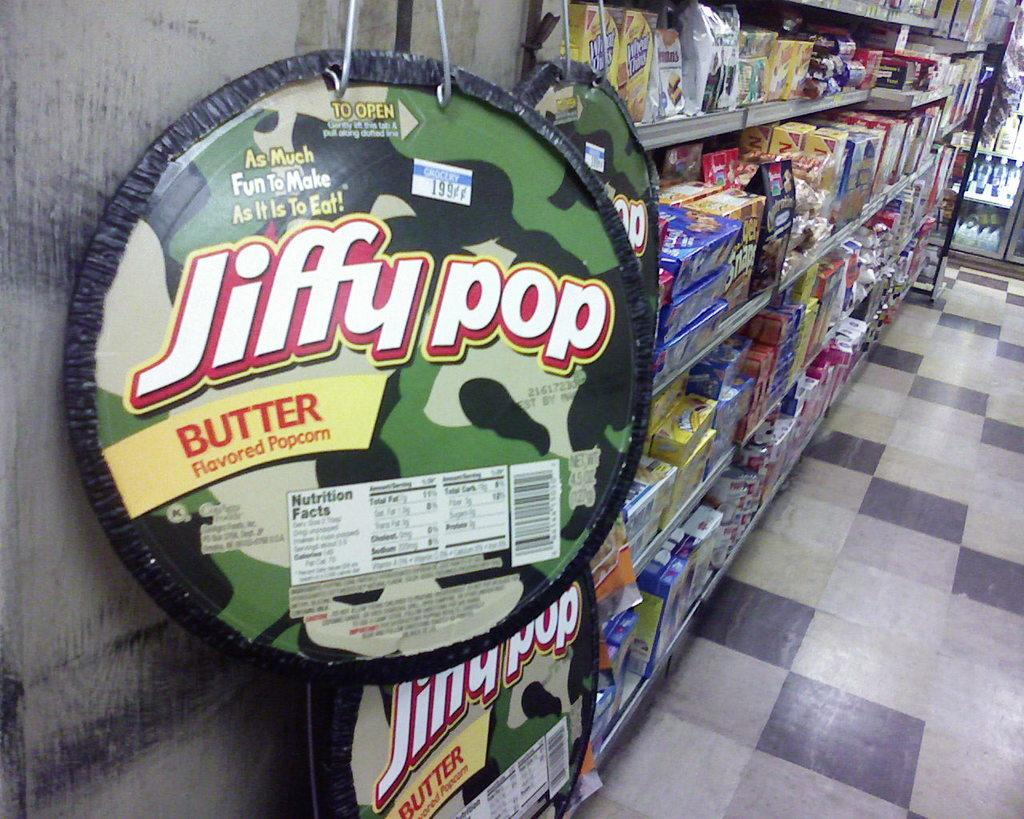<image>
Provide a brief description of the given image. A camouflage container of Jiffy Pop butter flavored popcorn. 